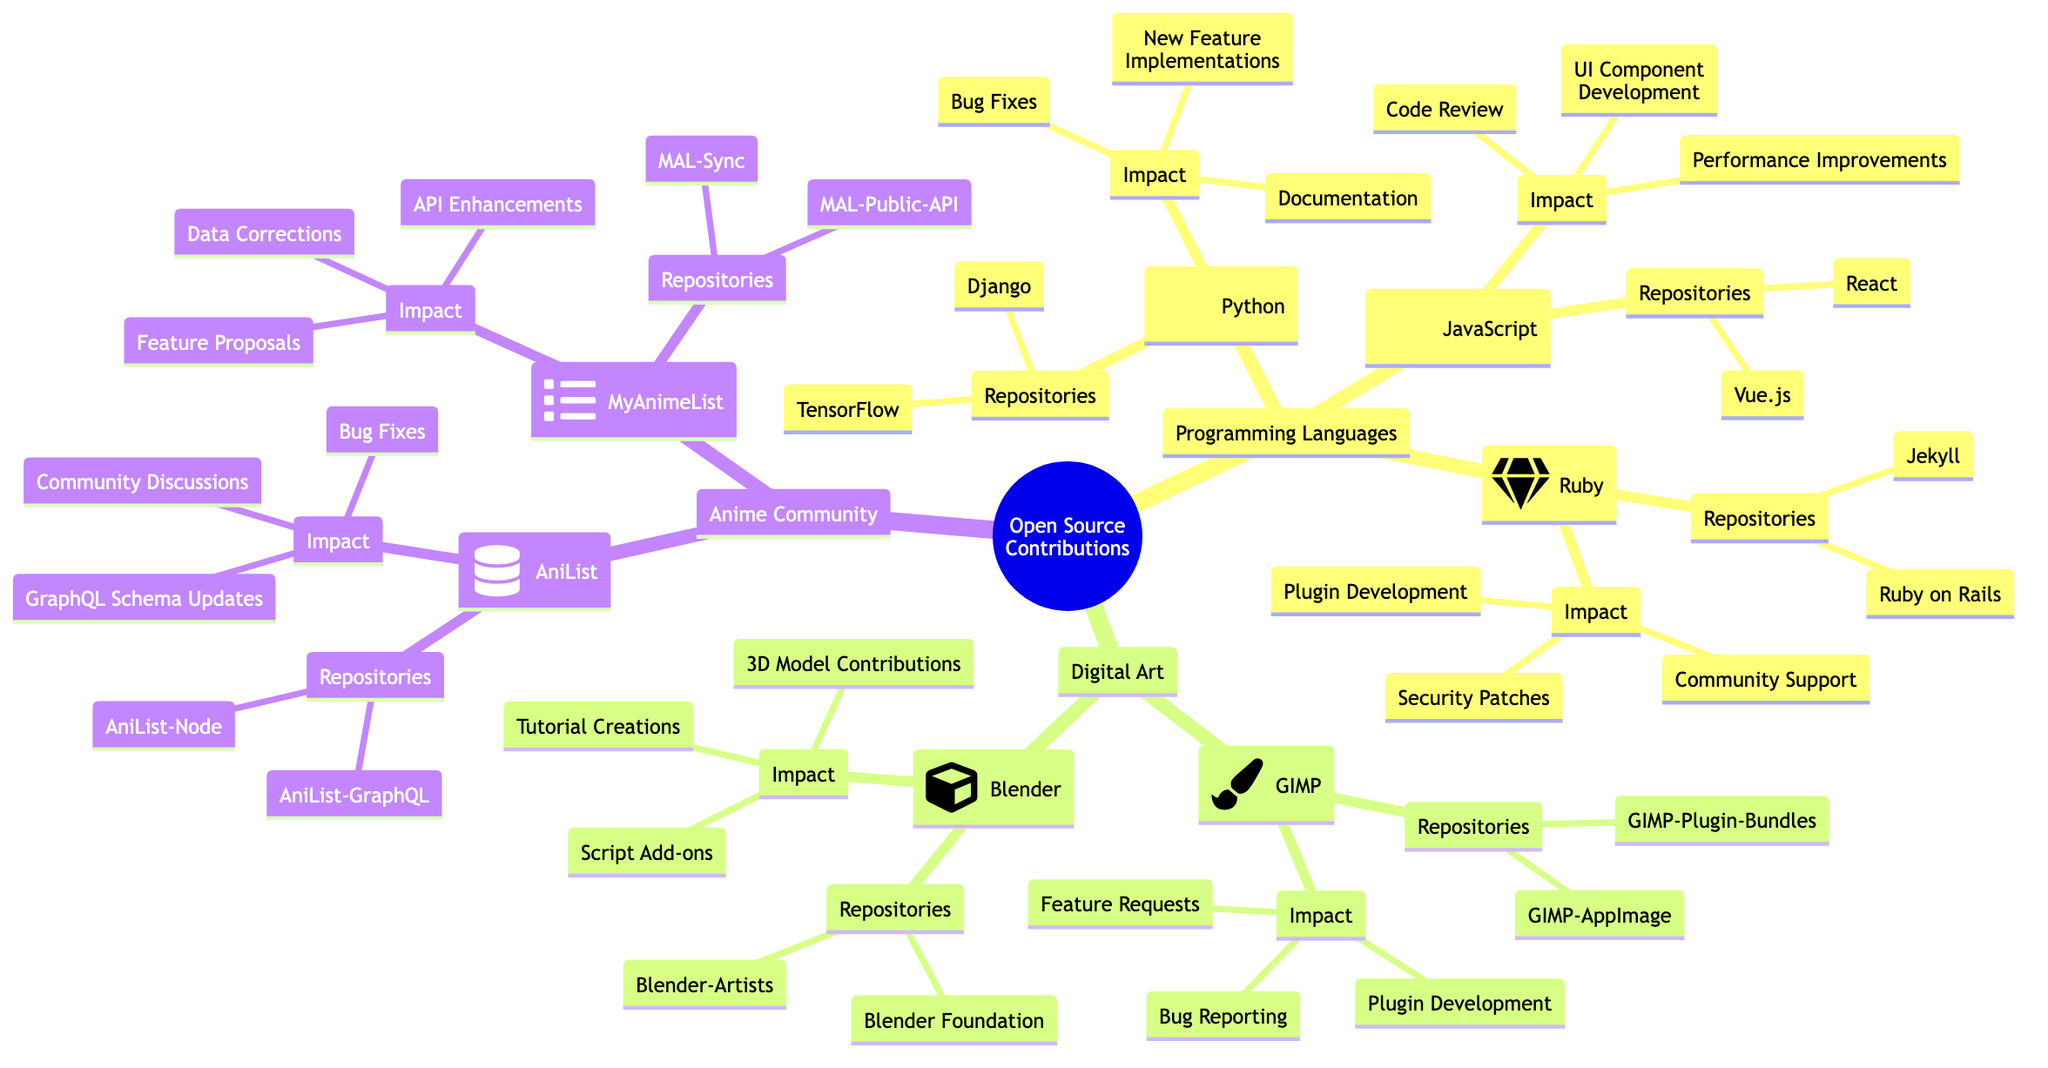What are the two programming languages listed under "Programming Languages"? The node "Programming Languages" branches into three languages: Python, JavaScript, and Ruby. However, the question specifically asks for two of them. Choosing any two from Python, JavaScript, or Ruby satisfies the question.
Answer: Python, JavaScript How many repositories are associated with GIMP? Under the "GIMP" node in the "Digital Art" section, there are two listed repositories: GIMP-AppImage and GIMP-Plugin-Bundles. Thus, the answer is simply the count of these repositories.
Answer: 2 What impact contributions are associated with "AniList"? The node "AniList" under "Anime Community Contributions" lists three impacts: GraphQL Schema Updates, Community Discussions, and Bug Fixes. Therefore, the answer is directly derived from reading this list under the specific node.
Answer: GraphQL Schema Updates, Community Discussions, Bug Fixes Which open source programming language has a contribution regarding "API Enhancements"? The "API Enhancements" is listed under the "MyAnimeList" node, which falls under "Anime Community Contributions". MyAnimeList is associated with contributions rather than programming languages; thus, this can be perceived as a reasoning question that involves understanding which contributions belong where.
Answer: MyAnimeList What is the impact of contributions in PHP? The diagram does not include PHP as one of the programming languages under contributions. The question requires recognizing the absence of PHP in the diagram. Hence, the answer is derived from identifying the lack of representation for that language.
Answer: None How many different types of impacts are listed under "JavaScript"? The node for "JavaScript" lists three specific impacts: UI Component Development, Performance Improvements, and Code Review. The answer is obtained by counting these features directly.
Answer: 3 What is the total number of different languages and tools listed in the diagram? The diagram includes three programming languages (Python, JavaScript, Ruby) and two tools (GIMP, Blender), giving a total count. By adding these, the answer follows.
Answer: 5 Which JavaScript repository focuses on UI components? Under "JavaScript," the repository "React" is specifically associated with UI Component Development, indicated in the impact section. Therefore, the analysis is straightforward once the term focus is understood relative to the repository listing.
Answer: React 